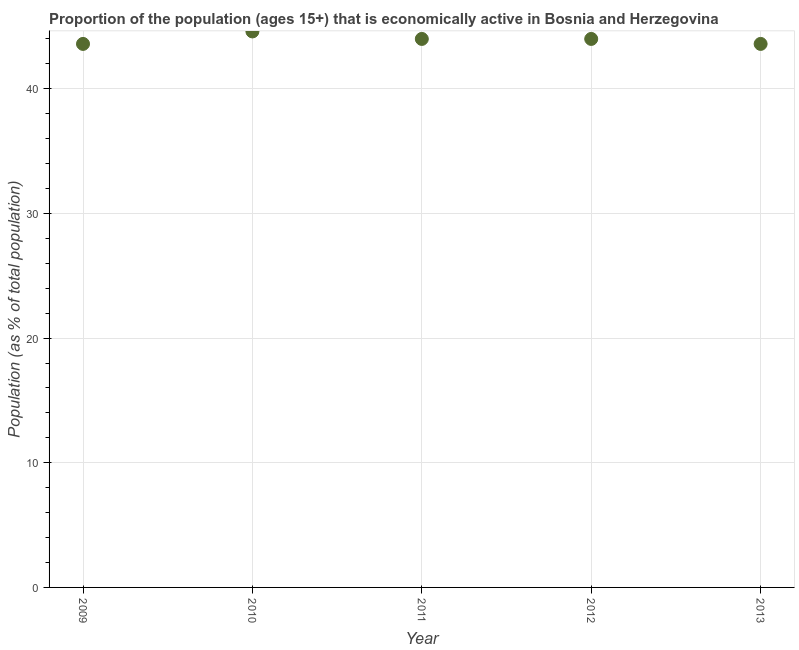What is the percentage of economically active population in 2009?
Your answer should be very brief. 43.6. Across all years, what is the maximum percentage of economically active population?
Your response must be concise. 44.6. Across all years, what is the minimum percentage of economically active population?
Ensure brevity in your answer.  43.6. In which year was the percentage of economically active population minimum?
Make the answer very short. 2009. What is the sum of the percentage of economically active population?
Provide a short and direct response. 219.8. What is the difference between the percentage of economically active population in 2010 and 2012?
Provide a short and direct response. 0.6. What is the average percentage of economically active population per year?
Your answer should be very brief. 43.96. Do a majority of the years between 2013 and 2012 (inclusive) have percentage of economically active population greater than 30 %?
Give a very brief answer. No. What is the ratio of the percentage of economically active population in 2011 to that in 2012?
Your answer should be very brief. 1. Is the percentage of economically active population in 2012 less than that in 2013?
Your answer should be very brief. No. Is the difference between the percentage of economically active population in 2011 and 2013 greater than the difference between any two years?
Provide a succinct answer. No. What is the difference between the highest and the second highest percentage of economically active population?
Your answer should be compact. 0.6. In how many years, is the percentage of economically active population greater than the average percentage of economically active population taken over all years?
Your answer should be very brief. 3. Does the percentage of economically active population monotonically increase over the years?
Your response must be concise. No. How many dotlines are there?
Your answer should be compact. 1. Are the values on the major ticks of Y-axis written in scientific E-notation?
Keep it short and to the point. No. Does the graph contain grids?
Your response must be concise. Yes. What is the title of the graph?
Provide a succinct answer. Proportion of the population (ages 15+) that is economically active in Bosnia and Herzegovina. What is the label or title of the X-axis?
Provide a succinct answer. Year. What is the label or title of the Y-axis?
Provide a succinct answer. Population (as % of total population). What is the Population (as % of total population) in 2009?
Your answer should be very brief. 43.6. What is the Population (as % of total population) in 2010?
Offer a very short reply. 44.6. What is the Population (as % of total population) in 2011?
Your response must be concise. 44. What is the Population (as % of total population) in 2012?
Your answer should be compact. 44. What is the Population (as % of total population) in 2013?
Your answer should be compact. 43.6. What is the difference between the Population (as % of total population) in 2009 and 2010?
Your answer should be very brief. -1. What is the difference between the Population (as % of total population) in 2009 and 2011?
Ensure brevity in your answer.  -0.4. What is the difference between the Population (as % of total population) in 2009 and 2012?
Provide a short and direct response. -0.4. What is the difference between the Population (as % of total population) in 2009 and 2013?
Your answer should be very brief. 0. What is the difference between the Population (as % of total population) in 2011 and 2013?
Make the answer very short. 0.4. What is the difference between the Population (as % of total population) in 2012 and 2013?
Offer a very short reply. 0.4. What is the ratio of the Population (as % of total population) in 2009 to that in 2012?
Your response must be concise. 0.99. What is the ratio of the Population (as % of total population) in 2011 to that in 2012?
Ensure brevity in your answer.  1. What is the ratio of the Population (as % of total population) in 2012 to that in 2013?
Your answer should be very brief. 1.01. 